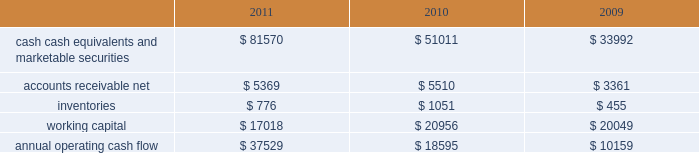35% ( 35 % ) due primarily to certain undistributed foreign earnings for which no u.s .
Taxes are provided because such earnings are intended to be indefinitely reinvested outside the u.s .
As of september 24 , 2011 , the company had deferred tax assets arising from deductible temporary differences , tax losses , and tax credits of $ 3.2 billion , and deferred tax liabilities of $ 9.2 billion .
Management believes it is more likely than not that forecasted income , including income that may be generated as a result of certain tax planning strategies , together with future reversals of existing taxable temporary differences , will be sufficient to fully recover the deferred tax assets .
The company will continue to evaluate the realizability of deferred tax assets quarterly by assessing the need for and amount of a valuation allowance .
The internal revenue service ( the 201cirs 201d ) has completed its field audit of the company 2019s federal income tax returns for the years 2004 through 2006 and proposed certain adjustments .
The company has contested certain of these adjustments through the irs appeals office .
The irs is currently examining the years 2007 through 2009 .
All irs audit issues for years prior to 2004 have been resolved .
In addition , the company is subject to audits by state , local , and foreign tax authorities .
Management believes that adequate provisions have been made for any adjustments that may result from tax examinations .
However , the outcome of tax audits cannot be predicted with certainty .
If any issues addressed in the company 2019s tax audits are resolved in a manner not consistent with management 2019s expectations , the company could be required to adjust its provision for income taxes in the period such resolution occurs .
Liquidity and capital resources the table presents selected financial information and statistics as of and for the three years ended september 24 , 2011 ( in millions ) : .
Cash , cash equivalents and marketable securities increased $ 30.6 billion or 60% ( 60 % ) during 2011 .
The principal components of this net increase was the cash generated by operating activities of $ 37.5 billion , which was partially offset by payments for acquisition of property , plant and equipment of $ 4.3 billion , payments for acquisition of intangible assets of $ 3.2 billion and payments made in connection with business acquisitions , net of cash acquired , of $ 244 million .
The company believes its existing balances of cash , cash equivalents and marketable securities will be sufficient to satisfy its working capital needs , capital asset purchases , outstanding commitments and other liquidity requirements associated with its existing operations over the next 12 months .
The company 2019s marketable securities investment portfolio is invested primarily in highly rated securities and its policy generally limits the amount of credit exposure to any one issuer .
The company 2019s investment policy requires investments to generally be investment grade with the objective of minimizing the potential risk of principal loss .
As of september 24 , 2011 and september 25 , 2010 , $ 54.3 billion and $ 30.8 billion , respectively , of the company 2019s cash , cash equivalents and marketable securities were held by foreign subsidiaries and are generally based in u.s .
Dollar-denominated holdings .
Amounts held by foreign subsidiaries are generally subject to u.s .
Income taxation on repatriation to the u.s .
Capital assets the company 2019s capital expenditures were $ 4.6 billion during 2011 , consisting of approximately $ 614 million for retail store facilities and $ 4.0 billion for other capital expenditures , including product tooling and manufacturing .
What is the percentage change in annual operating cash flow from 2010 to 2011? 
Computations: ((37529 - 18595) / 18595)
Answer: 1.01823. 